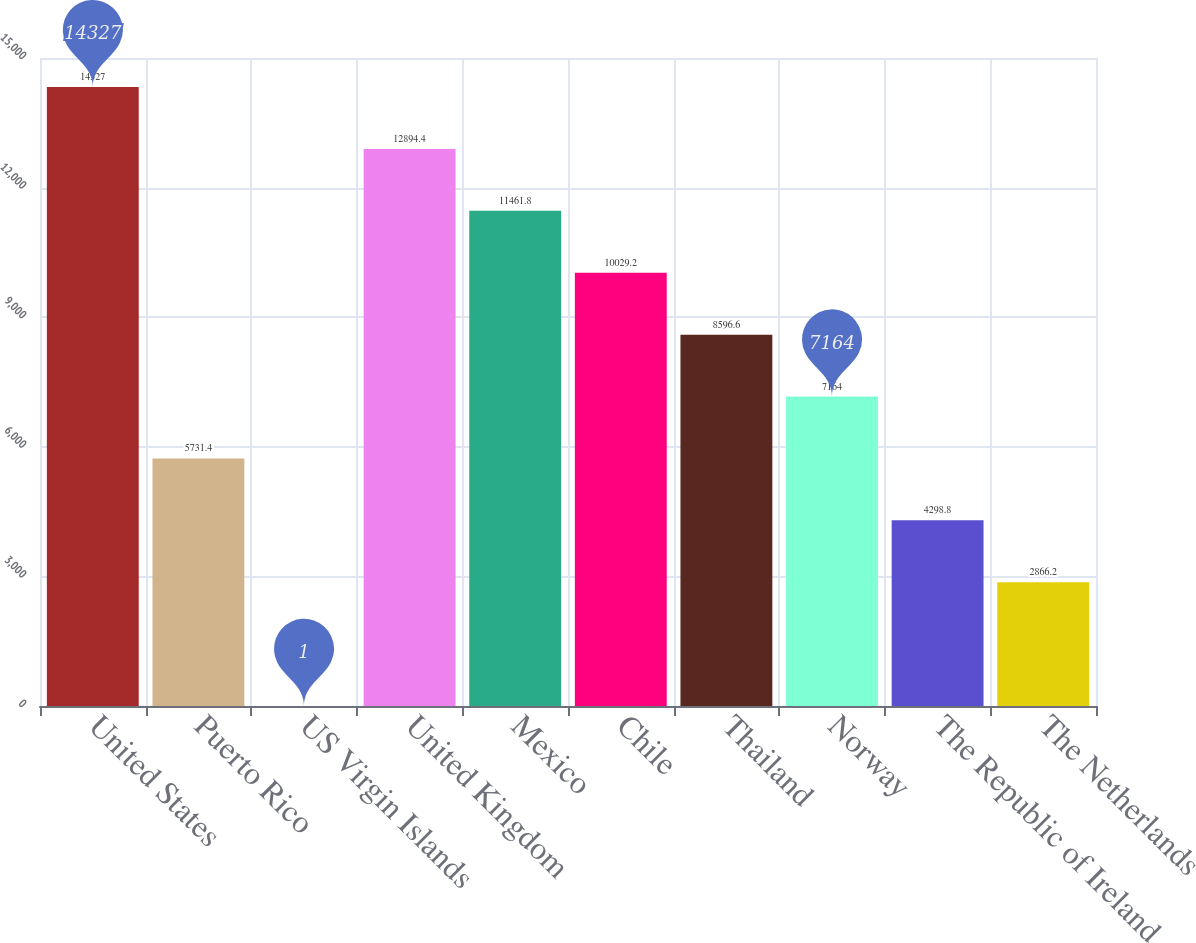<chart> <loc_0><loc_0><loc_500><loc_500><bar_chart><fcel>United States<fcel>Puerto Rico<fcel>US Virgin Islands<fcel>United Kingdom<fcel>Mexico<fcel>Chile<fcel>Thailand<fcel>Norway<fcel>The Republic of Ireland<fcel>The Netherlands<nl><fcel>14327<fcel>5731.4<fcel>1<fcel>12894.4<fcel>11461.8<fcel>10029.2<fcel>8596.6<fcel>7164<fcel>4298.8<fcel>2866.2<nl></chart> 